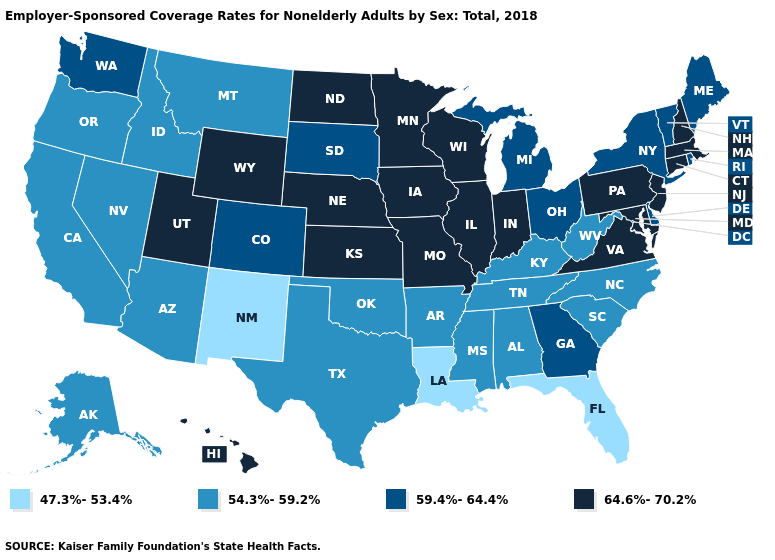Does Pennsylvania have the highest value in the USA?
Write a very short answer. Yes. Does Pennsylvania have the highest value in the USA?
Answer briefly. Yes. Which states have the highest value in the USA?
Write a very short answer. Connecticut, Hawaii, Illinois, Indiana, Iowa, Kansas, Maryland, Massachusetts, Minnesota, Missouri, Nebraska, New Hampshire, New Jersey, North Dakota, Pennsylvania, Utah, Virginia, Wisconsin, Wyoming. Among the states that border New Jersey , which have the highest value?
Write a very short answer. Pennsylvania. What is the highest value in states that border Louisiana?
Concise answer only. 54.3%-59.2%. Among the states that border Kansas , which have the highest value?
Concise answer only. Missouri, Nebraska. Is the legend a continuous bar?
Answer briefly. No. Which states have the lowest value in the USA?
Give a very brief answer. Florida, Louisiana, New Mexico. Is the legend a continuous bar?
Write a very short answer. No. What is the value of Texas?
Write a very short answer. 54.3%-59.2%. What is the highest value in the South ?
Quick response, please. 64.6%-70.2%. Name the states that have a value in the range 59.4%-64.4%?
Quick response, please. Colorado, Delaware, Georgia, Maine, Michigan, New York, Ohio, Rhode Island, South Dakota, Vermont, Washington. What is the highest value in the USA?
Write a very short answer. 64.6%-70.2%. What is the lowest value in states that border Ohio?
Give a very brief answer. 54.3%-59.2%. 